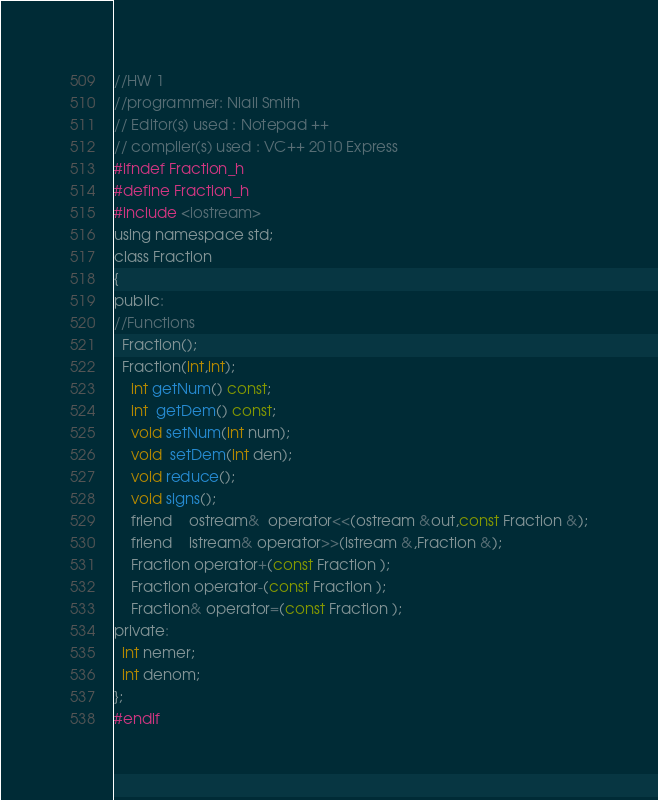<code> <loc_0><loc_0><loc_500><loc_500><_C_>//HW 1
//programmer: Niall Smith
// Editor(s) used : Notepad ++
// compiler(s) used : VC++ 2010 Express
#ifndef Fraction_h
#define Fraction_h
#include <iostream>
using namespace std;
class Fraction
{
public:
//Functions
  Fraction();
  Fraction(int,int); 
	int getNum() const;
	int  getDem() const;
	void setNum(int num);
	void  setDem(int den);
	void reduce();
	void signs();
	friend	ostream&  operator<<(ostream &out,const Fraction &);
	friend	istream& operator>>(istream &,Fraction &);
	Fraction operator+(const Fraction );
	Fraction operator-(const Fraction );
	Fraction& operator=(const Fraction );
private: 
  int nemer;
  int denom;
};
#endif</code> 